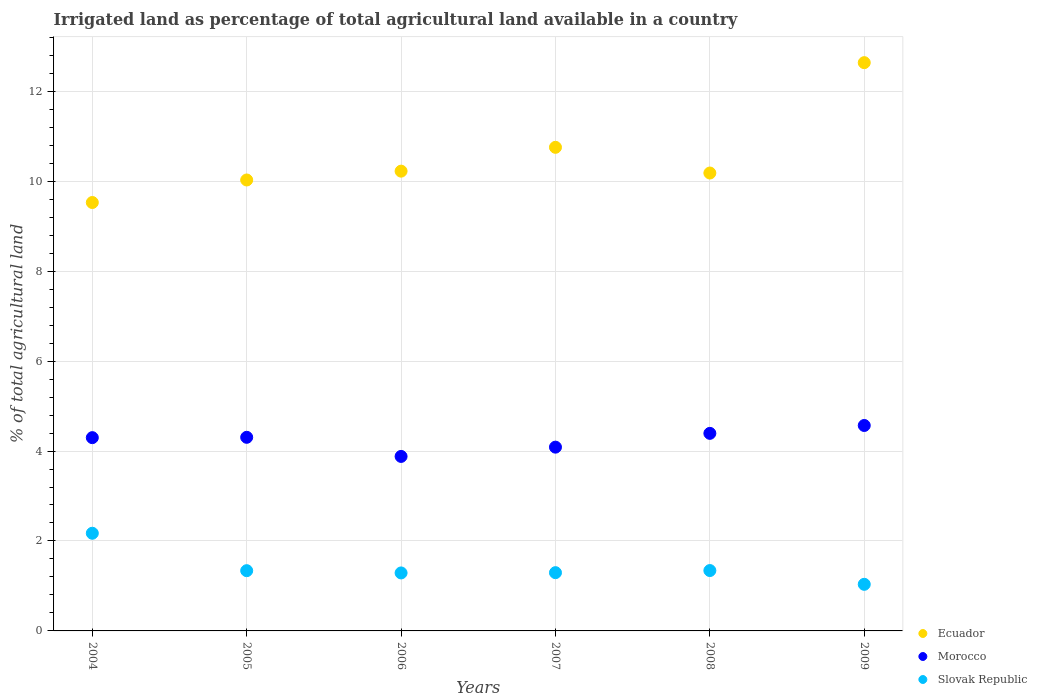Is the number of dotlines equal to the number of legend labels?
Your answer should be compact. Yes. What is the percentage of irrigated land in Slovak Republic in 2006?
Provide a short and direct response. 1.29. Across all years, what is the maximum percentage of irrigated land in Slovak Republic?
Provide a short and direct response. 2.17. Across all years, what is the minimum percentage of irrigated land in Morocco?
Provide a succinct answer. 3.88. In which year was the percentage of irrigated land in Slovak Republic maximum?
Your answer should be very brief. 2004. What is the total percentage of irrigated land in Ecuador in the graph?
Your response must be concise. 63.34. What is the difference between the percentage of irrigated land in Slovak Republic in 2007 and that in 2009?
Provide a short and direct response. 0.26. What is the difference between the percentage of irrigated land in Morocco in 2005 and the percentage of irrigated land in Ecuador in 2009?
Your response must be concise. -8.33. What is the average percentage of irrigated land in Ecuador per year?
Offer a terse response. 10.56. In the year 2008, what is the difference between the percentage of irrigated land in Ecuador and percentage of irrigated land in Slovak Republic?
Keep it short and to the point. 8.84. What is the ratio of the percentage of irrigated land in Ecuador in 2007 to that in 2008?
Ensure brevity in your answer.  1.06. Is the percentage of irrigated land in Morocco in 2004 less than that in 2007?
Provide a short and direct response. No. Is the difference between the percentage of irrigated land in Ecuador in 2004 and 2005 greater than the difference between the percentage of irrigated land in Slovak Republic in 2004 and 2005?
Your response must be concise. No. What is the difference between the highest and the second highest percentage of irrigated land in Ecuador?
Make the answer very short. 1.88. What is the difference between the highest and the lowest percentage of irrigated land in Slovak Republic?
Offer a terse response. 1.14. Is it the case that in every year, the sum of the percentage of irrigated land in Morocco and percentage of irrigated land in Ecuador  is greater than the percentage of irrigated land in Slovak Republic?
Provide a succinct answer. Yes. Does the percentage of irrigated land in Ecuador monotonically increase over the years?
Your answer should be very brief. No. Is the percentage of irrigated land in Ecuador strictly greater than the percentage of irrigated land in Slovak Republic over the years?
Keep it short and to the point. Yes. Is the percentage of irrigated land in Ecuador strictly less than the percentage of irrigated land in Morocco over the years?
Provide a short and direct response. No. What is the difference between two consecutive major ticks on the Y-axis?
Your answer should be compact. 2. Are the values on the major ticks of Y-axis written in scientific E-notation?
Your answer should be compact. No. How many legend labels are there?
Provide a short and direct response. 3. How are the legend labels stacked?
Provide a succinct answer. Vertical. What is the title of the graph?
Ensure brevity in your answer.  Irrigated land as percentage of total agricultural land available in a country. What is the label or title of the Y-axis?
Ensure brevity in your answer.  % of total agricultural land. What is the % of total agricultural land of Ecuador in 2004?
Give a very brief answer. 9.53. What is the % of total agricultural land in Morocco in 2004?
Keep it short and to the point. 4.3. What is the % of total agricultural land of Slovak Republic in 2004?
Provide a succinct answer. 2.17. What is the % of total agricultural land of Ecuador in 2005?
Ensure brevity in your answer.  10.03. What is the % of total agricultural land in Morocco in 2005?
Provide a short and direct response. 4.3. What is the % of total agricultural land of Slovak Republic in 2005?
Make the answer very short. 1.34. What is the % of total agricultural land of Ecuador in 2006?
Your response must be concise. 10.22. What is the % of total agricultural land of Morocco in 2006?
Your answer should be compact. 3.88. What is the % of total agricultural land in Slovak Republic in 2006?
Keep it short and to the point. 1.29. What is the % of total agricultural land of Ecuador in 2007?
Provide a succinct answer. 10.75. What is the % of total agricultural land in Morocco in 2007?
Give a very brief answer. 4.09. What is the % of total agricultural land in Slovak Republic in 2007?
Provide a short and direct response. 1.3. What is the % of total agricultural land of Ecuador in 2008?
Give a very brief answer. 10.18. What is the % of total agricultural land of Morocco in 2008?
Your answer should be very brief. 4.39. What is the % of total agricultural land of Slovak Republic in 2008?
Your answer should be very brief. 1.34. What is the % of total agricultural land in Ecuador in 2009?
Keep it short and to the point. 12.64. What is the % of total agricultural land of Morocco in 2009?
Your answer should be very brief. 4.57. What is the % of total agricultural land of Slovak Republic in 2009?
Your answer should be very brief. 1.04. Across all years, what is the maximum % of total agricultural land of Ecuador?
Give a very brief answer. 12.64. Across all years, what is the maximum % of total agricultural land in Morocco?
Your answer should be compact. 4.57. Across all years, what is the maximum % of total agricultural land in Slovak Republic?
Your response must be concise. 2.17. Across all years, what is the minimum % of total agricultural land of Ecuador?
Your response must be concise. 9.53. Across all years, what is the minimum % of total agricultural land of Morocco?
Your answer should be very brief. 3.88. Across all years, what is the minimum % of total agricultural land in Slovak Republic?
Offer a very short reply. 1.04. What is the total % of total agricultural land of Ecuador in the graph?
Provide a short and direct response. 63.34. What is the total % of total agricultural land of Morocco in the graph?
Your answer should be very brief. 25.53. What is the total % of total agricultural land of Slovak Republic in the graph?
Make the answer very short. 8.47. What is the difference between the % of total agricultural land in Ecuador in 2004 and that in 2005?
Give a very brief answer. -0.5. What is the difference between the % of total agricultural land in Morocco in 2004 and that in 2005?
Make the answer very short. -0.01. What is the difference between the % of total agricultural land in Slovak Republic in 2004 and that in 2005?
Make the answer very short. 0.83. What is the difference between the % of total agricultural land of Ecuador in 2004 and that in 2006?
Make the answer very short. -0.7. What is the difference between the % of total agricultural land of Morocco in 2004 and that in 2006?
Your response must be concise. 0.42. What is the difference between the % of total agricultural land in Slovak Republic in 2004 and that in 2006?
Keep it short and to the point. 0.88. What is the difference between the % of total agricultural land in Ecuador in 2004 and that in 2007?
Your answer should be very brief. -1.23. What is the difference between the % of total agricultural land of Morocco in 2004 and that in 2007?
Offer a very short reply. 0.21. What is the difference between the % of total agricultural land of Slovak Republic in 2004 and that in 2007?
Offer a terse response. 0.88. What is the difference between the % of total agricultural land in Ecuador in 2004 and that in 2008?
Give a very brief answer. -0.66. What is the difference between the % of total agricultural land of Morocco in 2004 and that in 2008?
Keep it short and to the point. -0.1. What is the difference between the % of total agricultural land in Slovak Republic in 2004 and that in 2008?
Ensure brevity in your answer.  0.83. What is the difference between the % of total agricultural land of Ecuador in 2004 and that in 2009?
Your answer should be very brief. -3.11. What is the difference between the % of total agricultural land of Morocco in 2004 and that in 2009?
Provide a succinct answer. -0.27. What is the difference between the % of total agricultural land of Slovak Republic in 2004 and that in 2009?
Your response must be concise. 1.14. What is the difference between the % of total agricultural land of Ecuador in 2005 and that in 2006?
Offer a very short reply. -0.2. What is the difference between the % of total agricultural land in Morocco in 2005 and that in 2006?
Ensure brevity in your answer.  0.42. What is the difference between the % of total agricultural land of Slovak Republic in 2005 and that in 2006?
Ensure brevity in your answer.  0.05. What is the difference between the % of total agricultural land in Ecuador in 2005 and that in 2007?
Make the answer very short. -0.73. What is the difference between the % of total agricultural land of Morocco in 2005 and that in 2007?
Keep it short and to the point. 0.22. What is the difference between the % of total agricultural land in Slovak Republic in 2005 and that in 2007?
Give a very brief answer. 0.04. What is the difference between the % of total agricultural land in Ecuador in 2005 and that in 2008?
Provide a short and direct response. -0.15. What is the difference between the % of total agricultural land of Morocco in 2005 and that in 2008?
Provide a succinct answer. -0.09. What is the difference between the % of total agricultural land in Slovak Republic in 2005 and that in 2008?
Ensure brevity in your answer.  -0. What is the difference between the % of total agricultural land of Ecuador in 2005 and that in 2009?
Your response must be concise. -2.61. What is the difference between the % of total agricultural land in Morocco in 2005 and that in 2009?
Provide a short and direct response. -0.26. What is the difference between the % of total agricultural land in Slovak Republic in 2005 and that in 2009?
Offer a terse response. 0.3. What is the difference between the % of total agricultural land of Ecuador in 2006 and that in 2007?
Ensure brevity in your answer.  -0.53. What is the difference between the % of total agricultural land of Morocco in 2006 and that in 2007?
Provide a short and direct response. -0.21. What is the difference between the % of total agricultural land in Slovak Republic in 2006 and that in 2007?
Ensure brevity in your answer.  -0.01. What is the difference between the % of total agricultural land in Ecuador in 2006 and that in 2008?
Keep it short and to the point. 0.04. What is the difference between the % of total agricultural land of Morocco in 2006 and that in 2008?
Make the answer very short. -0.51. What is the difference between the % of total agricultural land in Slovak Republic in 2006 and that in 2008?
Keep it short and to the point. -0.05. What is the difference between the % of total agricultural land of Ecuador in 2006 and that in 2009?
Your answer should be compact. -2.41. What is the difference between the % of total agricultural land in Morocco in 2006 and that in 2009?
Offer a terse response. -0.69. What is the difference between the % of total agricultural land in Slovak Republic in 2006 and that in 2009?
Your answer should be compact. 0.25. What is the difference between the % of total agricultural land in Ecuador in 2007 and that in 2008?
Offer a terse response. 0.57. What is the difference between the % of total agricultural land of Morocco in 2007 and that in 2008?
Offer a very short reply. -0.31. What is the difference between the % of total agricultural land in Slovak Republic in 2007 and that in 2008?
Make the answer very short. -0.05. What is the difference between the % of total agricultural land of Ecuador in 2007 and that in 2009?
Give a very brief answer. -1.88. What is the difference between the % of total agricultural land of Morocco in 2007 and that in 2009?
Make the answer very short. -0.48. What is the difference between the % of total agricultural land of Slovak Republic in 2007 and that in 2009?
Give a very brief answer. 0.26. What is the difference between the % of total agricultural land of Ecuador in 2008 and that in 2009?
Your answer should be very brief. -2.45. What is the difference between the % of total agricultural land in Morocco in 2008 and that in 2009?
Give a very brief answer. -0.18. What is the difference between the % of total agricultural land in Slovak Republic in 2008 and that in 2009?
Give a very brief answer. 0.31. What is the difference between the % of total agricultural land in Ecuador in 2004 and the % of total agricultural land in Morocco in 2005?
Your answer should be compact. 5.22. What is the difference between the % of total agricultural land of Ecuador in 2004 and the % of total agricultural land of Slovak Republic in 2005?
Provide a succinct answer. 8.19. What is the difference between the % of total agricultural land of Morocco in 2004 and the % of total agricultural land of Slovak Republic in 2005?
Offer a terse response. 2.96. What is the difference between the % of total agricultural land in Ecuador in 2004 and the % of total agricultural land in Morocco in 2006?
Give a very brief answer. 5.65. What is the difference between the % of total agricultural land in Ecuador in 2004 and the % of total agricultural land in Slovak Republic in 2006?
Your response must be concise. 8.24. What is the difference between the % of total agricultural land in Morocco in 2004 and the % of total agricultural land in Slovak Republic in 2006?
Give a very brief answer. 3.01. What is the difference between the % of total agricultural land in Ecuador in 2004 and the % of total agricultural land in Morocco in 2007?
Keep it short and to the point. 5.44. What is the difference between the % of total agricultural land in Ecuador in 2004 and the % of total agricultural land in Slovak Republic in 2007?
Provide a short and direct response. 8.23. What is the difference between the % of total agricultural land of Morocco in 2004 and the % of total agricultural land of Slovak Republic in 2007?
Your response must be concise. 3. What is the difference between the % of total agricultural land in Ecuador in 2004 and the % of total agricultural land in Morocco in 2008?
Your answer should be compact. 5.13. What is the difference between the % of total agricultural land in Ecuador in 2004 and the % of total agricultural land in Slovak Republic in 2008?
Your answer should be very brief. 8.18. What is the difference between the % of total agricultural land of Morocco in 2004 and the % of total agricultural land of Slovak Republic in 2008?
Your response must be concise. 2.96. What is the difference between the % of total agricultural land in Ecuador in 2004 and the % of total agricultural land in Morocco in 2009?
Offer a terse response. 4.96. What is the difference between the % of total agricultural land in Ecuador in 2004 and the % of total agricultural land in Slovak Republic in 2009?
Provide a short and direct response. 8.49. What is the difference between the % of total agricultural land of Morocco in 2004 and the % of total agricultural land of Slovak Republic in 2009?
Ensure brevity in your answer.  3.26. What is the difference between the % of total agricultural land of Ecuador in 2005 and the % of total agricultural land of Morocco in 2006?
Your answer should be compact. 6.15. What is the difference between the % of total agricultural land of Ecuador in 2005 and the % of total agricultural land of Slovak Republic in 2006?
Provide a short and direct response. 8.74. What is the difference between the % of total agricultural land of Morocco in 2005 and the % of total agricultural land of Slovak Republic in 2006?
Provide a succinct answer. 3.02. What is the difference between the % of total agricultural land in Ecuador in 2005 and the % of total agricultural land in Morocco in 2007?
Offer a very short reply. 5.94. What is the difference between the % of total agricultural land of Ecuador in 2005 and the % of total agricultural land of Slovak Republic in 2007?
Keep it short and to the point. 8.73. What is the difference between the % of total agricultural land of Morocco in 2005 and the % of total agricultural land of Slovak Republic in 2007?
Your response must be concise. 3.01. What is the difference between the % of total agricultural land in Ecuador in 2005 and the % of total agricultural land in Morocco in 2008?
Give a very brief answer. 5.63. What is the difference between the % of total agricultural land in Ecuador in 2005 and the % of total agricultural land in Slovak Republic in 2008?
Make the answer very short. 8.68. What is the difference between the % of total agricultural land of Morocco in 2005 and the % of total agricultural land of Slovak Republic in 2008?
Make the answer very short. 2.96. What is the difference between the % of total agricultural land in Ecuador in 2005 and the % of total agricultural land in Morocco in 2009?
Your answer should be very brief. 5.46. What is the difference between the % of total agricultural land in Ecuador in 2005 and the % of total agricultural land in Slovak Republic in 2009?
Provide a succinct answer. 8.99. What is the difference between the % of total agricultural land of Morocco in 2005 and the % of total agricultural land of Slovak Republic in 2009?
Ensure brevity in your answer.  3.27. What is the difference between the % of total agricultural land of Ecuador in 2006 and the % of total agricultural land of Morocco in 2007?
Ensure brevity in your answer.  6.14. What is the difference between the % of total agricultural land of Ecuador in 2006 and the % of total agricultural land of Slovak Republic in 2007?
Your response must be concise. 8.93. What is the difference between the % of total agricultural land of Morocco in 2006 and the % of total agricultural land of Slovak Republic in 2007?
Give a very brief answer. 2.58. What is the difference between the % of total agricultural land of Ecuador in 2006 and the % of total agricultural land of Morocco in 2008?
Offer a terse response. 5.83. What is the difference between the % of total agricultural land in Ecuador in 2006 and the % of total agricultural land in Slovak Republic in 2008?
Your response must be concise. 8.88. What is the difference between the % of total agricultural land of Morocco in 2006 and the % of total agricultural land of Slovak Republic in 2008?
Keep it short and to the point. 2.54. What is the difference between the % of total agricultural land in Ecuador in 2006 and the % of total agricultural land in Morocco in 2009?
Give a very brief answer. 5.66. What is the difference between the % of total agricultural land in Ecuador in 2006 and the % of total agricultural land in Slovak Republic in 2009?
Provide a short and direct response. 9.19. What is the difference between the % of total agricultural land of Morocco in 2006 and the % of total agricultural land of Slovak Republic in 2009?
Offer a very short reply. 2.84. What is the difference between the % of total agricultural land of Ecuador in 2007 and the % of total agricultural land of Morocco in 2008?
Your answer should be compact. 6.36. What is the difference between the % of total agricultural land of Ecuador in 2007 and the % of total agricultural land of Slovak Republic in 2008?
Your answer should be compact. 9.41. What is the difference between the % of total agricultural land of Morocco in 2007 and the % of total agricultural land of Slovak Republic in 2008?
Provide a succinct answer. 2.74. What is the difference between the % of total agricultural land in Ecuador in 2007 and the % of total agricultural land in Morocco in 2009?
Offer a terse response. 6.18. What is the difference between the % of total agricultural land of Ecuador in 2007 and the % of total agricultural land of Slovak Republic in 2009?
Make the answer very short. 9.72. What is the difference between the % of total agricultural land in Morocco in 2007 and the % of total agricultural land in Slovak Republic in 2009?
Give a very brief answer. 3.05. What is the difference between the % of total agricultural land of Ecuador in 2008 and the % of total agricultural land of Morocco in 2009?
Ensure brevity in your answer.  5.61. What is the difference between the % of total agricultural land of Ecuador in 2008 and the % of total agricultural land of Slovak Republic in 2009?
Provide a short and direct response. 9.15. What is the difference between the % of total agricultural land in Morocco in 2008 and the % of total agricultural land in Slovak Republic in 2009?
Your answer should be very brief. 3.36. What is the average % of total agricultural land of Ecuador per year?
Your answer should be compact. 10.56. What is the average % of total agricultural land of Morocco per year?
Offer a very short reply. 4.25. What is the average % of total agricultural land in Slovak Republic per year?
Offer a terse response. 1.41. In the year 2004, what is the difference between the % of total agricultural land of Ecuador and % of total agricultural land of Morocco?
Give a very brief answer. 5.23. In the year 2004, what is the difference between the % of total agricultural land in Ecuador and % of total agricultural land in Slovak Republic?
Offer a very short reply. 7.35. In the year 2004, what is the difference between the % of total agricultural land in Morocco and % of total agricultural land in Slovak Republic?
Ensure brevity in your answer.  2.13. In the year 2005, what is the difference between the % of total agricultural land in Ecuador and % of total agricultural land in Morocco?
Ensure brevity in your answer.  5.72. In the year 2005, what is the difference between the % of total agricultural land of Ecuador and % of total agricultural land of Slovak Republic?
Keep it short and to the point. 8.69. In the year 2005, what is the difference between the % of total agricultural land in Morocco and % of total agricultural land in Slovak Republic?
Your response must be concise. 2.97. In the year 2006, what is the difference between the % of total agricultural land of Ecuador and % of total agricultural land of Morocco?
Your answer should be compact. 6.34. In the year 2006, what is the difference between the % of total agricultural land of Ecuador and % of total agricultural land of Slovak Republic?
Offer a terse response. 8.93. In the year 2006, what is the difference between the % of total agricultural land in Morocco and % of total agricultural land in Slovak Republic?
Provide a succinct answer. 2.59. In the year 2007, what is the difference between the % of total agricultural land of Ecuador and % of total agricultural land of Slovak Republic?
Your answer should be very brief. 9.46. In the year 2007, what is the difference between the % of total agricultural land in Morocco and % of total agricultural land in Slovak Republic?
Offer a terse response. 2.79. In the year 2008, what is the difference between the % of total agricultural land of Ecuador and % of total agricultural land of Morocco?
Offer a terse response. 5.79. In the year 2008, what is the difference between the % of total agricultural land in Ecuador and % of total agricultural land in Slovak Republic?
Offer a very short reply. 8.84. In the year 2008, what is the difference between the % of total agricultural land in Morocco and % of total agricultural land in Slovak Republic?
Give a very brief answer. 3.05. In the year 2009, what is the difference between the % of total agricultural land of Ecuador and % of total agricultural land of Morocco?
Provide a succinct answer. 8.07. In the year 2009, what is the difference between the % of total agricultural land of Ecuador and % of total agricultural land of Slovak Republic?
Provide a succinct answer. 11.6. In the year 2009, what is the difference between the % of total agricultural land of Morocco and % of total agricultural land of Slovak Republic?
Offer a terse response. 3.53. What is the ratio of the % of total agricultural land of Morocco in 2004 to that in 2005?
Provide a short and direct response. 1. What is the ratio of the % of total agricultural land of Slovak Republic in 2004 to that in 2005?
Ensure brevity in your answer.  1.62. What is the ratio of the % of total agricultural land of Ecuador in 2004 to that in 2006?
Provide a short and direct response. 0.93. What is the ratio of the % of total agricultural land in Morocco in 2004 to that in 2006?
Provide a succinct answer. 1.11. What is the ratio of the % of total agricultural land in Slovak Republic in 2004 to that in 2006?
Keep it short and to the point. 1.68. What is the ratio of the % of total agricultural land in Ecuador in 2004 to that in 2007?
Make the answer very short. 0.89. What is the ratio of the % of total agricultural land of Morocco in 2004 to that in 2007?
Offer a very short reply. 1.05. What is the ratio of the % of total agricultural land in Slovak Republic in 2004 to that in 2007?
Keep it short and to the point. 1.68. What is the ratio of the % of total agricultural land of Ecuador in 2004 to that in 2008?
Keep it short and to the point. 0.94. What is the ratio of the % of total agricultural land in Morocco in 2004 to that in 2008?
Provide a succinct answer. 0.98. What is the ratio of the % of total agricultural land in Slovak Republic in 2004 to that in 2008?
Make the answer very short. 1.62. What is the ratio of the % of total agricultural land in Ecuador in 2004 to that in 2009?
Provide a short and direct response. 0.75. What is the ratio of the % of total agricultural land in Morocco in 2004 to that in 2009?
Keep it short and to the point. 0.94. What is the ratio of the % of total agricultural land of Slovak Republic in 2004 to that in 2009?
Ensure brevity in your answer.  2.1. What is the ratio of the % of total agricultural land in Ecuador in 2005 to that in 2006?
Offer a very short reply. 0.98. What is the ratio of the % of total agricultural land of Morocco in 2005 to that in 2006?
Your answer should be very brief. 1.11. What is the ratio of the % of total agricultural land of Slovak Republic in 2005 to that in 2006?
Your answer should be very brief. 1.04. What is the ratio of the % of total agricultural land of Ecuador in 2005 to that in 2007?
Provide a succinct answer. 0.93. What is the ratio of the % of total agricultural land in Morocco in 2005 to that in 2007?
Keep it short and to the point. 1.05. What is the ratio of the % of total agricultural land of Slovak Republic in 2005 to that in 2007?
Your response must be concise. 1.03. What is the ratio of the % of total agricultural land in Morocco in 2005 to that in 2008?
Provide a succinct answer. 0.98. What is the ratio of the % of total agricultural land in Slovak Republic in 2005 to that in 2008?
Provide a short and direct response. 1. What is the ratio of the % of total agricultural land of Ecuador in 2005 to that in 2009?
Make the answer very short. 0.79. What is the ratio of the % of total agricultural land in Morocco in 2005 to that in 2009?
Provide a short and direct response. 0.94. What is the ratio of the % of total agricultural land in Slovak Republic in 2005 to that in 2009?
Ensure brevity in your answer.  1.29. What is the ratio of the % of total agricultural land of Ecuador in 2006 to that in 2007?
Your answer should be very brief. 0.95. What is the ratio of the % of total agricultural land of Morocco in 2006 to that in 2007?
Provide a short and direct response. 0.95. What is the ratio of the % of total agricultural land of Ecuador in 2006 to that in 2008?
Your answer should be compact. 1. What is the ratio of the % of total agricultural land of Morocco in 2006 to that in 2008?
Your answer should be very brief. 0.88. What is the ratio of the % of total agricultural land of Slovak Republic in 2006 to that in 2008?
Make the answer very short. 0.96. What is the ratio of the % of total agricultural land in Ecuador in 2006 to that in 2009?
Offer a very short reply. 0.81. What is the ratio of the % of total agricultural land in Morocco in 2006 to that in 2009?
Provide a short and direct response. 0.85. What is the ratio of the % of total agricultural land in Slovak Republic in 2006 to that in 2009?
Give a very brief answer. 1.24. What is the ratio of the % of total agricultural land of Ecuador in 2007 to that in 2008?
Provide a short and direct response. 1.06. What is the ratio of the % of total agricultural land in Morocco in 2007 to that in 2008?
Make the answer very short. 0.93. What is the ratio of the % of total agricultural land of Slovak Republic in 2007 to that in 2008?
Make the answer very short. 0.96. What is the ratio of the % of total agricultural land of Ecuador in 2007 to that in 2009?
Your answer should be very brief. 0.85. What is the ratio of the % of total agricultural land of Morocco in 2007 to that in 2009?
Provide a short and direct response. 0.89. What is the ratio of the % of total agricultural land in Ecuador in 2008 to that in 2009?
Your answer should be very brief. 0.81. What is the ratio of the % of total agricultural land in Morocco in 2008 to that in 2009?
Your response must be concise. 0.96. What is the ratio of the % of total agricultural land of Slovak Republic in 2008 to that in 2009?
Ensure brevity in your answer.  1.3. What is the difference between the highest and the second highest % of total agricultural land in Ecuador?
Your answer should be very brief. 1.88. What is the difference between the highest and the second highest % of total agricultural land in Morocco?
Your answer should be very brief. 0.18. What is the difference between the highest and the second highest % of total agricultural land in Slovak Republic?
Offer a very short reply. 0.83. What is the difference between the highest and the lowest % of total agricultural land in Ecuador?
Offer a terse response. 3.11. What is the difference between the highest and the lowest % of total agricultural land of Morocco?
Offer a terse response. 0.69. What is the difference between the highest and the lowest % of total agricultural land in Slovak Republic?
Make the answer very short. 1.14. 